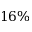Convert formula to latex. <formula><loc_0><loc_0><loc_500><loc_500>1 6 \%</formula> 